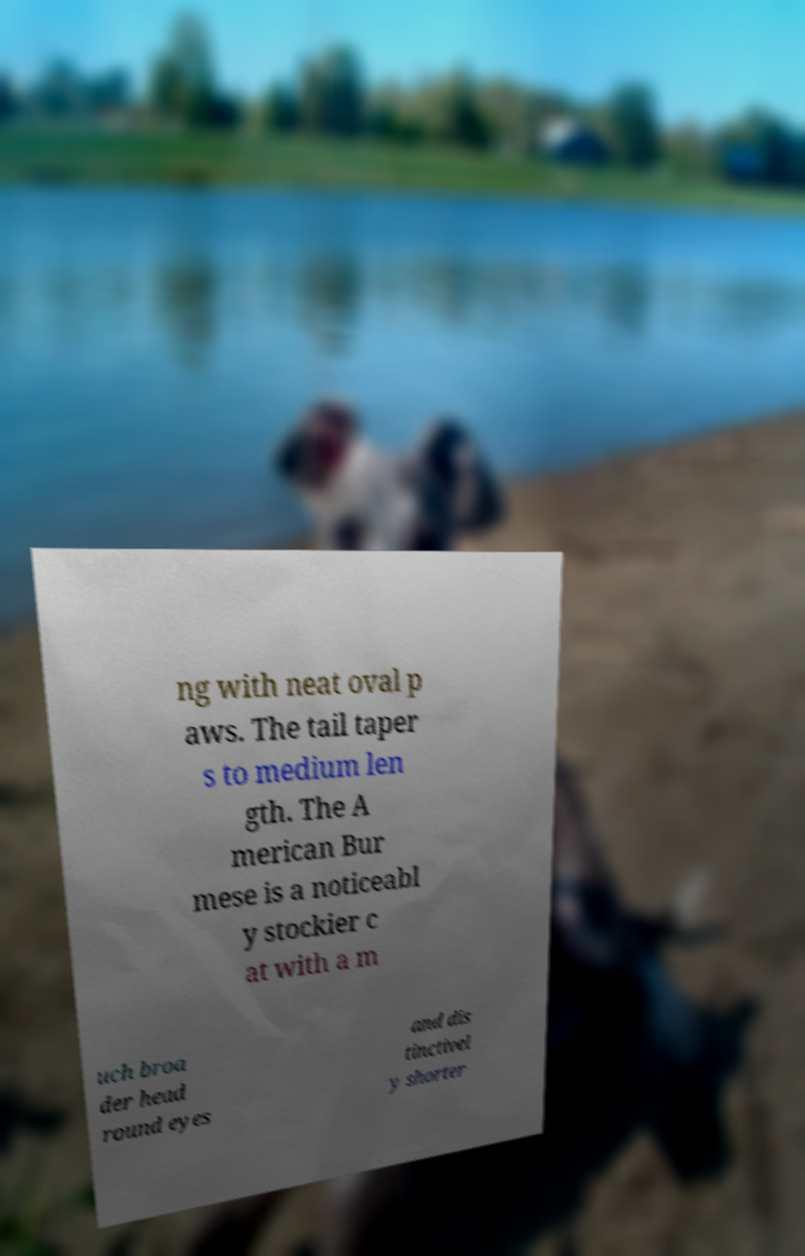What messages or text are displayed in this image? I need them in a readable, typed format. ng with neat oval p aws. The tail taper s to medium len gth. The A merican Bur mese is a noticeabl y stockier c at with a m uch broa der head round eyes and dis tinctivel y shorter 